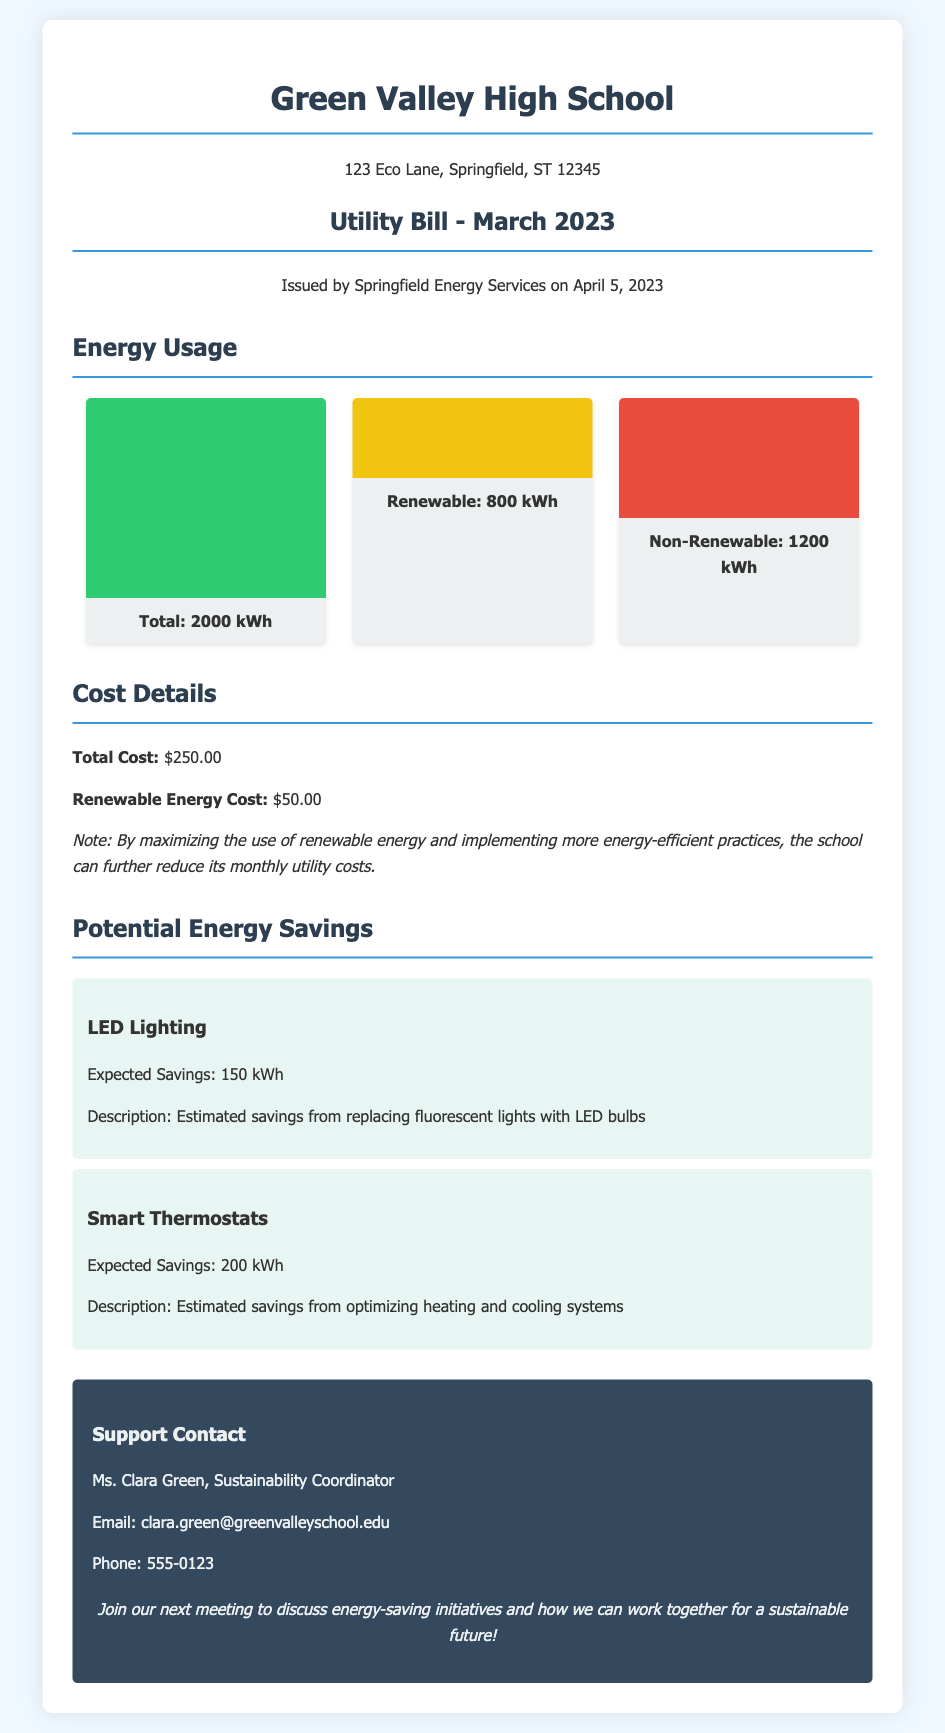What is the total energy usage for March 2023? The total energy usage is clearly mentioned in the document as 2000 kWh.
Answer: 2000 kWh How much energy was sourced from renewable options? The document specifies that renewable energy usage was 800 kWh.
Answer: 800 kWh What is the total cost of the utility bill? The document states the total cost is $250.00.
Answer: $250.00 What is the expected savings from LED lighting? The document lists the expected savings from LED lighting as 150 kWh.
Answer: 150 kWh Who is the Sustainability Coordinator? The document identifies Ms. Clara Green as the Sustainability Coordinator.
Answer: Ms. Clara Green What percentage of energy usage was non-renewable? The total non-renewable energy usage is 1200 kWh out of 2000 kWh, which calculates to 60%.
Answer: 60% What is the cost associated with renewable energy? According to the document, the cost for renewable energy is $50.00.
Answer: $50.00 What are the expected savings from using smart thermostats? The expected savings from smart thermostats is mentioned as 200 kWh.
Answer: 200 kWh What is the purpose of the call-to-action in the document? The call-to-action encourages participation in the meeting to discuss sustainability initiatives.
Answer: Discuss energy-saving initiatives 